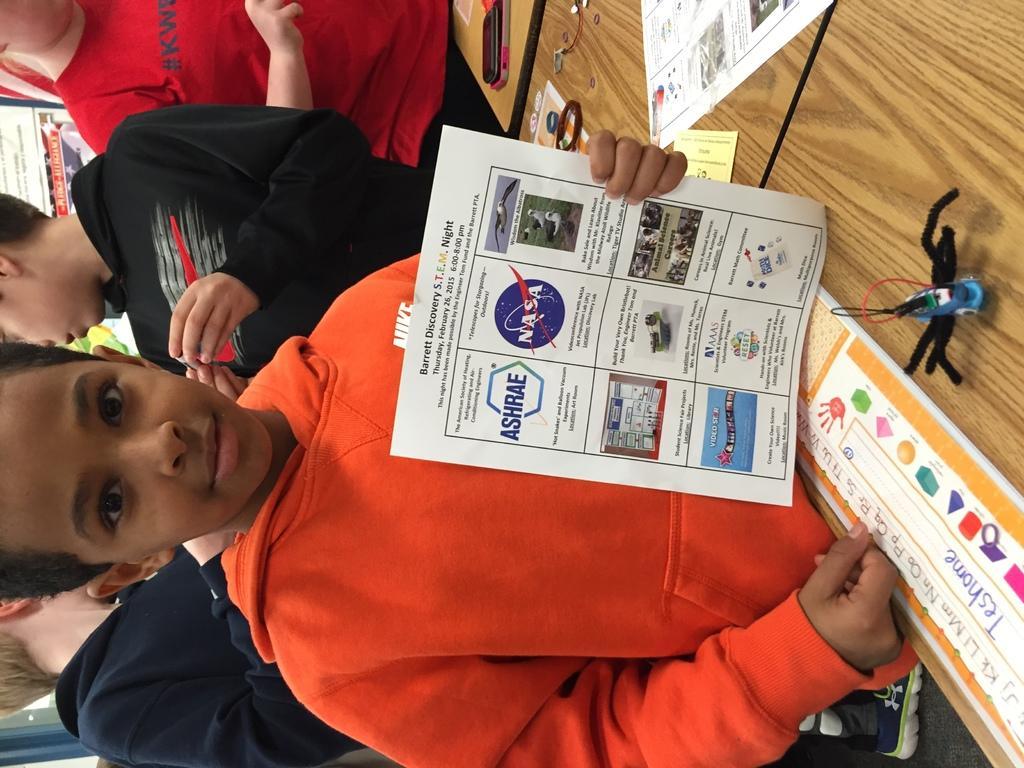Describe this image in one or two sentences. In this image we can see people, posters with some text and we can also see the wooden object. 